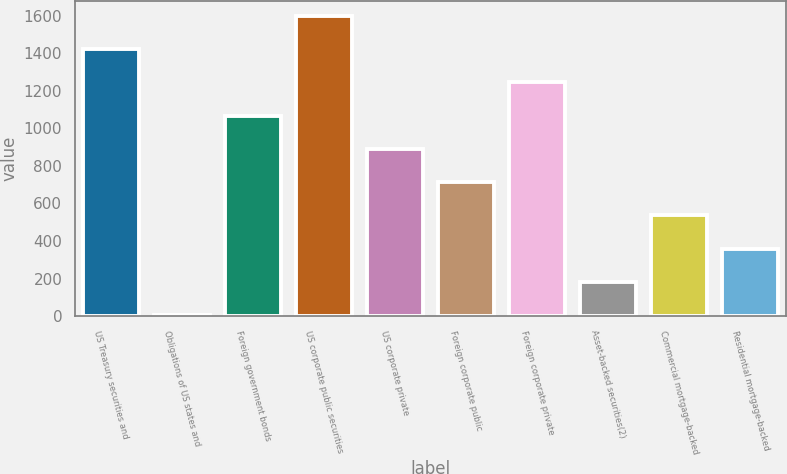Convert chart. <chart><loc_0><loc_0><loc_500><loc_500><bar_chart><fcel>US Treasury securities and<fcel>Obligations of US states and<fcel>Foreign government bonds<fcel>US corporate public securities<fcel>US corporate private<fcel>Foreign corporate public<fcel>Foreign corporate private<fcel>Asset-backed securities(2)<fcel>Commercial mortgage-backed<fcel>Residential mortgage-backed<nl><fcel>1422<fcel>6<fcel>1068<fcel>1599<fcel>891<fcel>714<fcel>1245<fcel>183<fcel>537<fcel>360<nl></chart> 